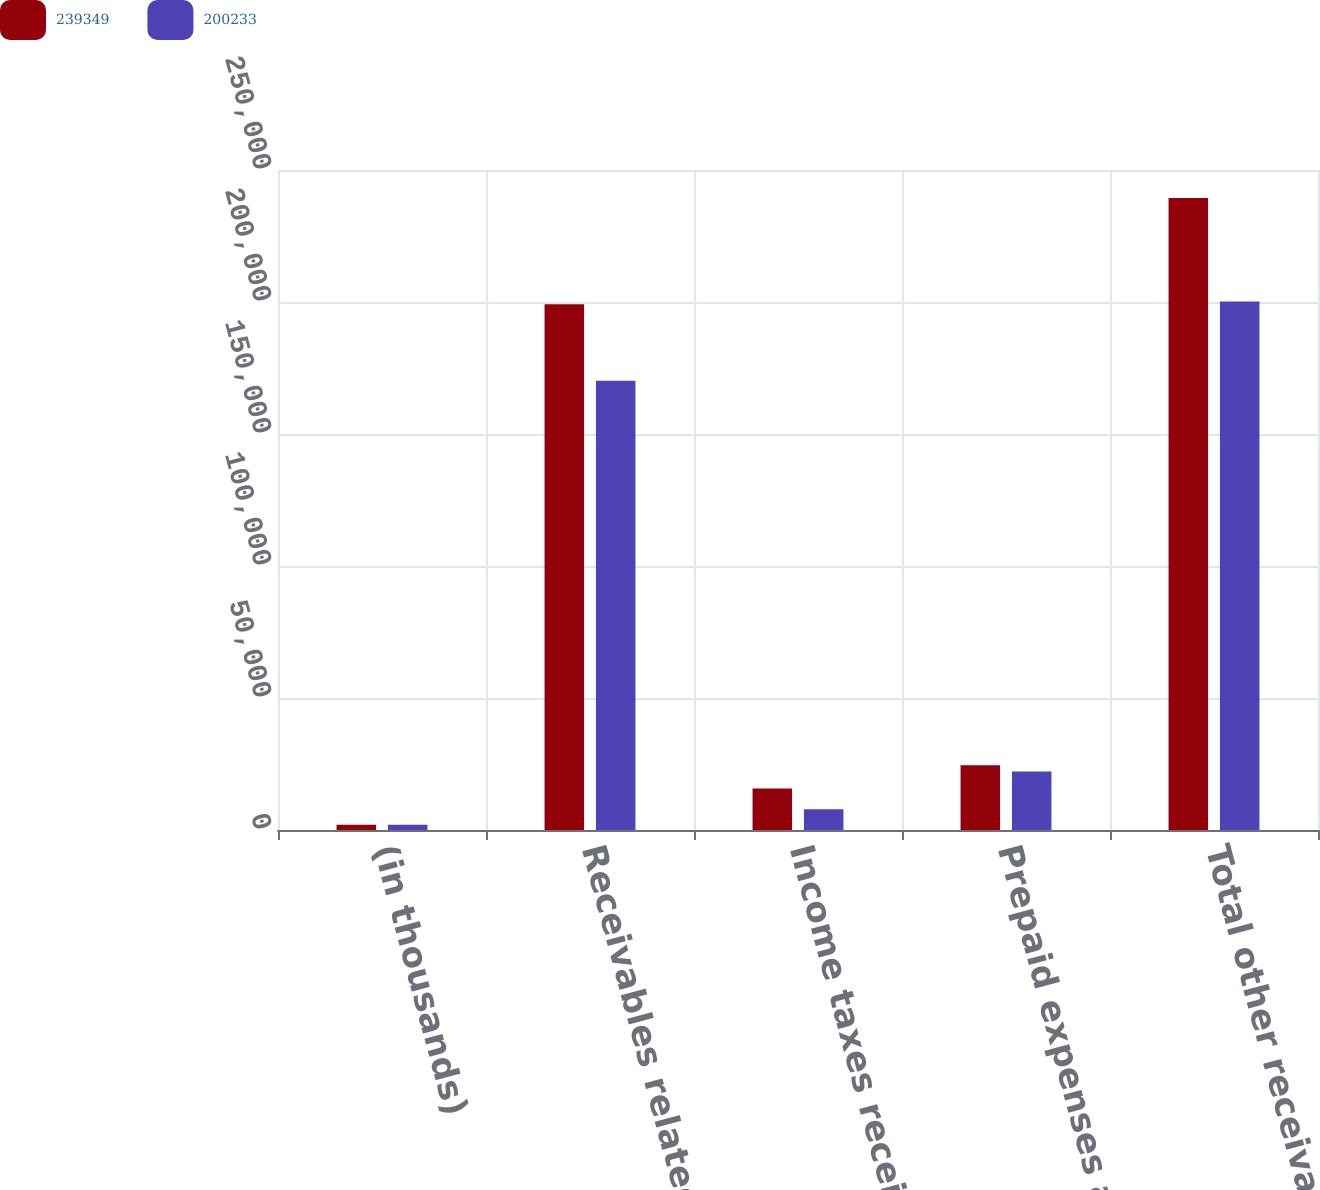Convert chart to OTSL. <chart><loc_0><loc_0><loc_500><loc_500><stacked_bar_chart><ecel><fcel>(in thousands)<fcel>Receivables related to<fcel>Income taxes receivable<fcel>Prepaid expenses and other<fcel>Total other receivables and<nl><fcel>239349<fcel>2016<fcel>199119<fcel>15718<fcel>24512<fcel>239349<nl><fcel>200233<fcel>2015<fcel>170186<fcel>7877<fcel>22170<fcel>200233<nl></chart> 